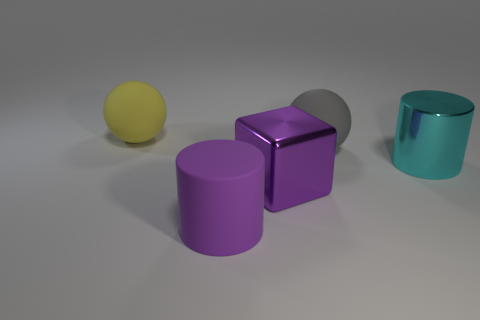There is a gray object that is made of the same material as the yellow thing; what is its shape?
Your answer should be compact. Sphere. The yellow matte thing has what shape?
Offer a very short reply. Sphere. There is a large rubber object that is behind the big block and on the right side of the large yellow matte object; what color is it?
Provide a short and direct response. Gray. What shape is the gray object that is the same size as the yellow thing?
Provide a succinct answer. Sphere. Is there another rubber object of the same shape as the large purple rubber thing?
Your answer should be compact. No. Do the big yellow object and the cube that is in front of the cyan object have the same material?
Give a very brief answer. No. There is a big rubber sphere that is in front of the large matte ball that is on the left side of the cylinder that is left of the large purple metallic thing; what color is it?
Ensure brevity in your answer.  Gray. What material is the gray sphere that is the same size as the purple rubber cylinder?
Your answer should be compact. Rubber. What number of cylinders have the same material as the large gray sphere?
Your response must be concise. 1. There is a metal thing in front of the big cyan cylinder; does it have the same size as the cylinder to the left of the cyan thing?
Your response must be concise. Yes. 